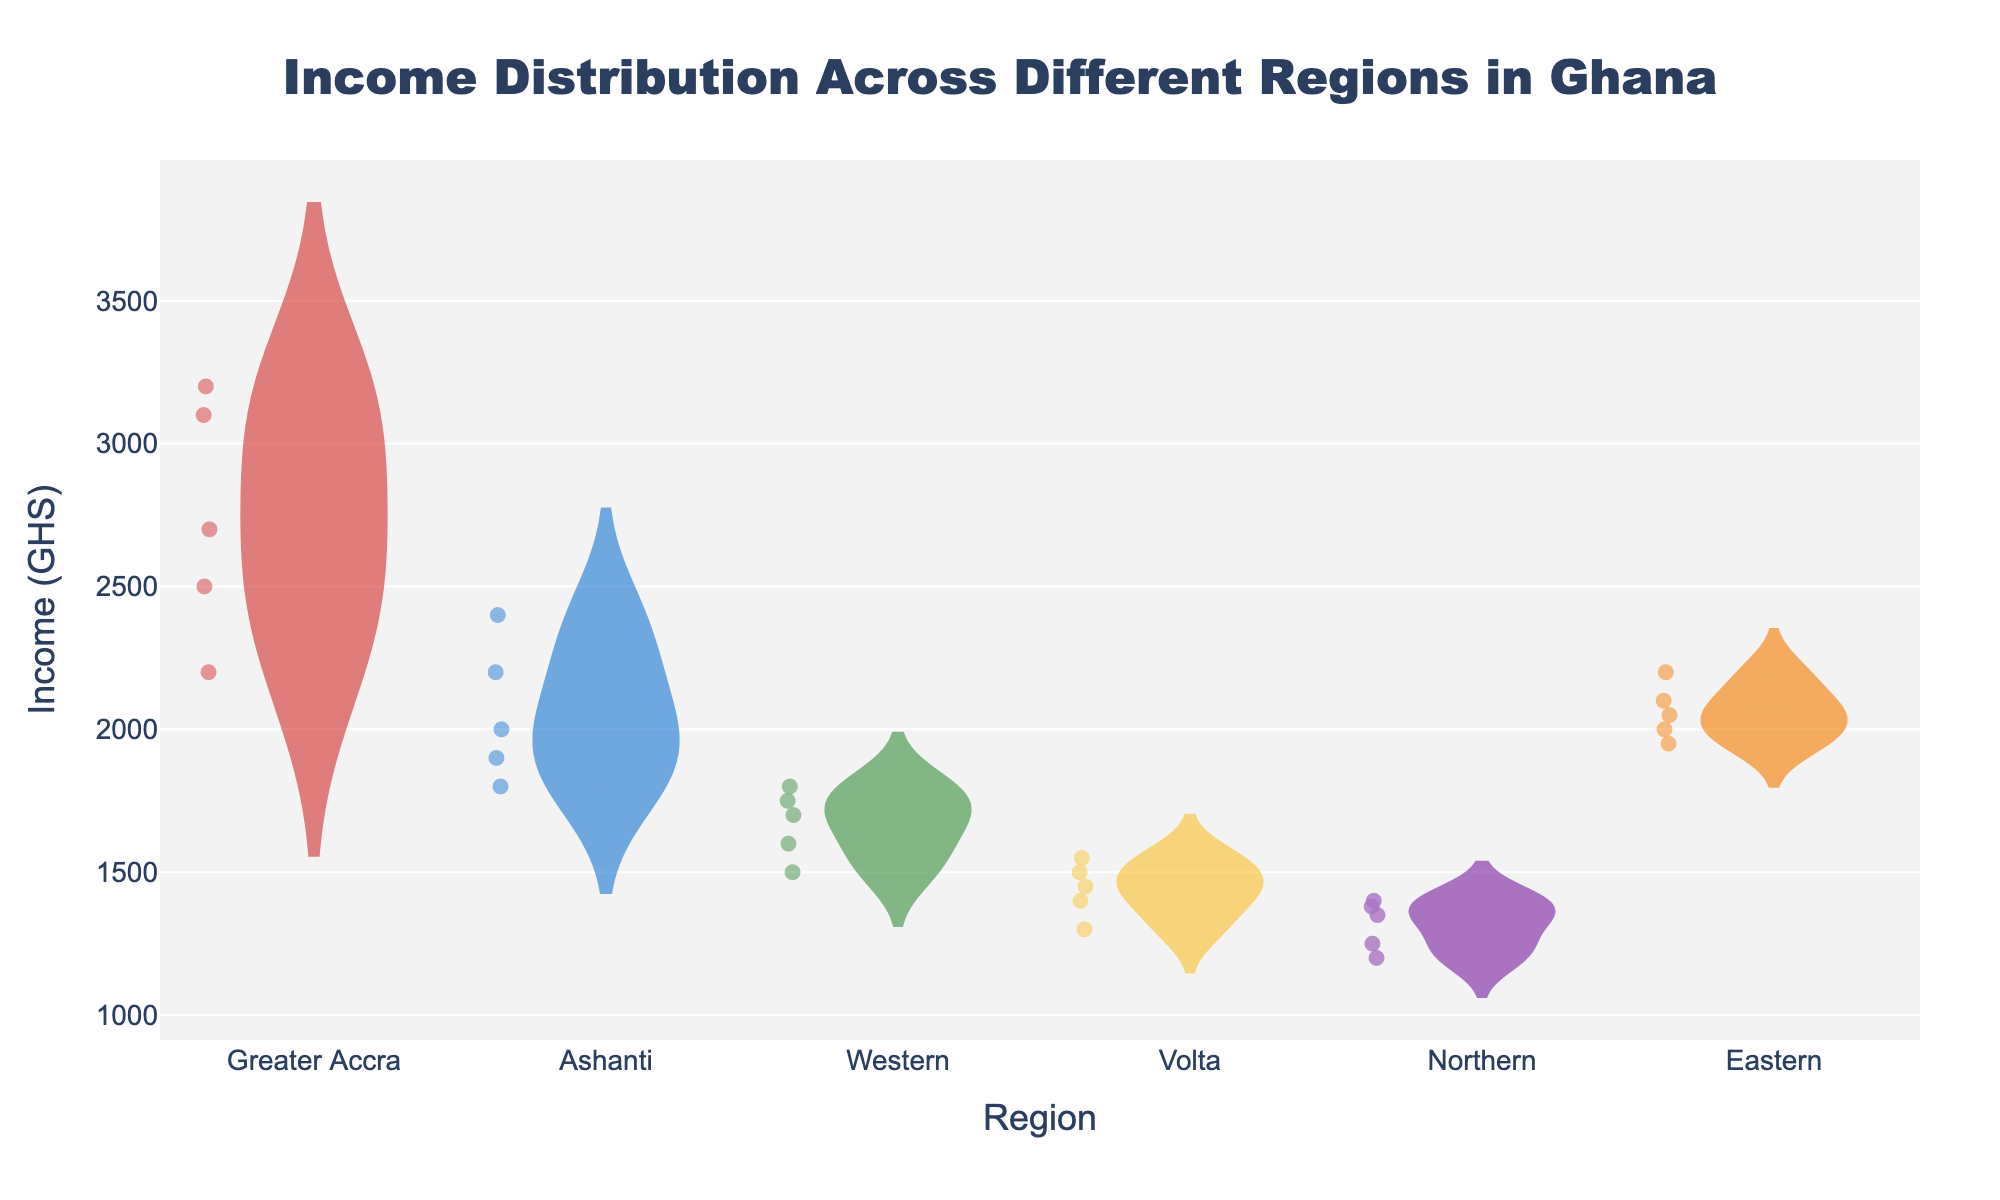What is the title of the figure? The title is displayed at the top center of the figure. It provides an overview of what the figure represents.
Answer: Income Distribution Across Different Regions in Ghana What does the y-axis represent? The y-axis is labeled on the left side of the figure. It indicates the variable being measured, which in this case is income in Ghanaian cedis (GHS).
Answer: Income (GHS) Which region has the highest income data point? By looking at the vertical extent of the data points in the figure, we observe that the highest point is in Greater Accra.
Answer: Greater Accra What is the median income in Greater Accra? The median is indicated by the line within the box plot overlaid on the violin plot for Greater Accra.
Answer: Around 2700 GHS Which region has the widest range of income distribution? The range can be determined by the length of the violin plot. Greater length indicates a wider range. Greater Accra has the widest range in this figure.
Answer: Greater Accra How does the income distribution in Eastern region compare with that in Northern region? Comparison can be made by visually observing the width and spread of the violin plots and the positions of the box plots. Eastern region has higher incomes overall compared to the Northern region.
Answer: Eastern has higher incomes Which region has the lowest recorded income? The lowest recorded income in the figure is observed at the bottom of the Northern region's violin plot.
Answer: Northern What feature represents the spread of individual data points within each region? This feature is indicated by the violin plot itself, which shows the density and spread of the incomes for each region.
Answer: Violin plot What is the primary difference between the violin plots of Ashanti and Volta regions? The Ashanti region's violin plot is more evenly distributed with a higher overall income, whereas the Volta region’s has a lower income and a narrower distribution.
Answer: Ashanti is more evenly distributed and higher What do the box plots within the violin plots signify? The box plots provide additional statistical information like the quartiles, median, and potential outliers of the income data for each region.
Answer: Quartiles and median 